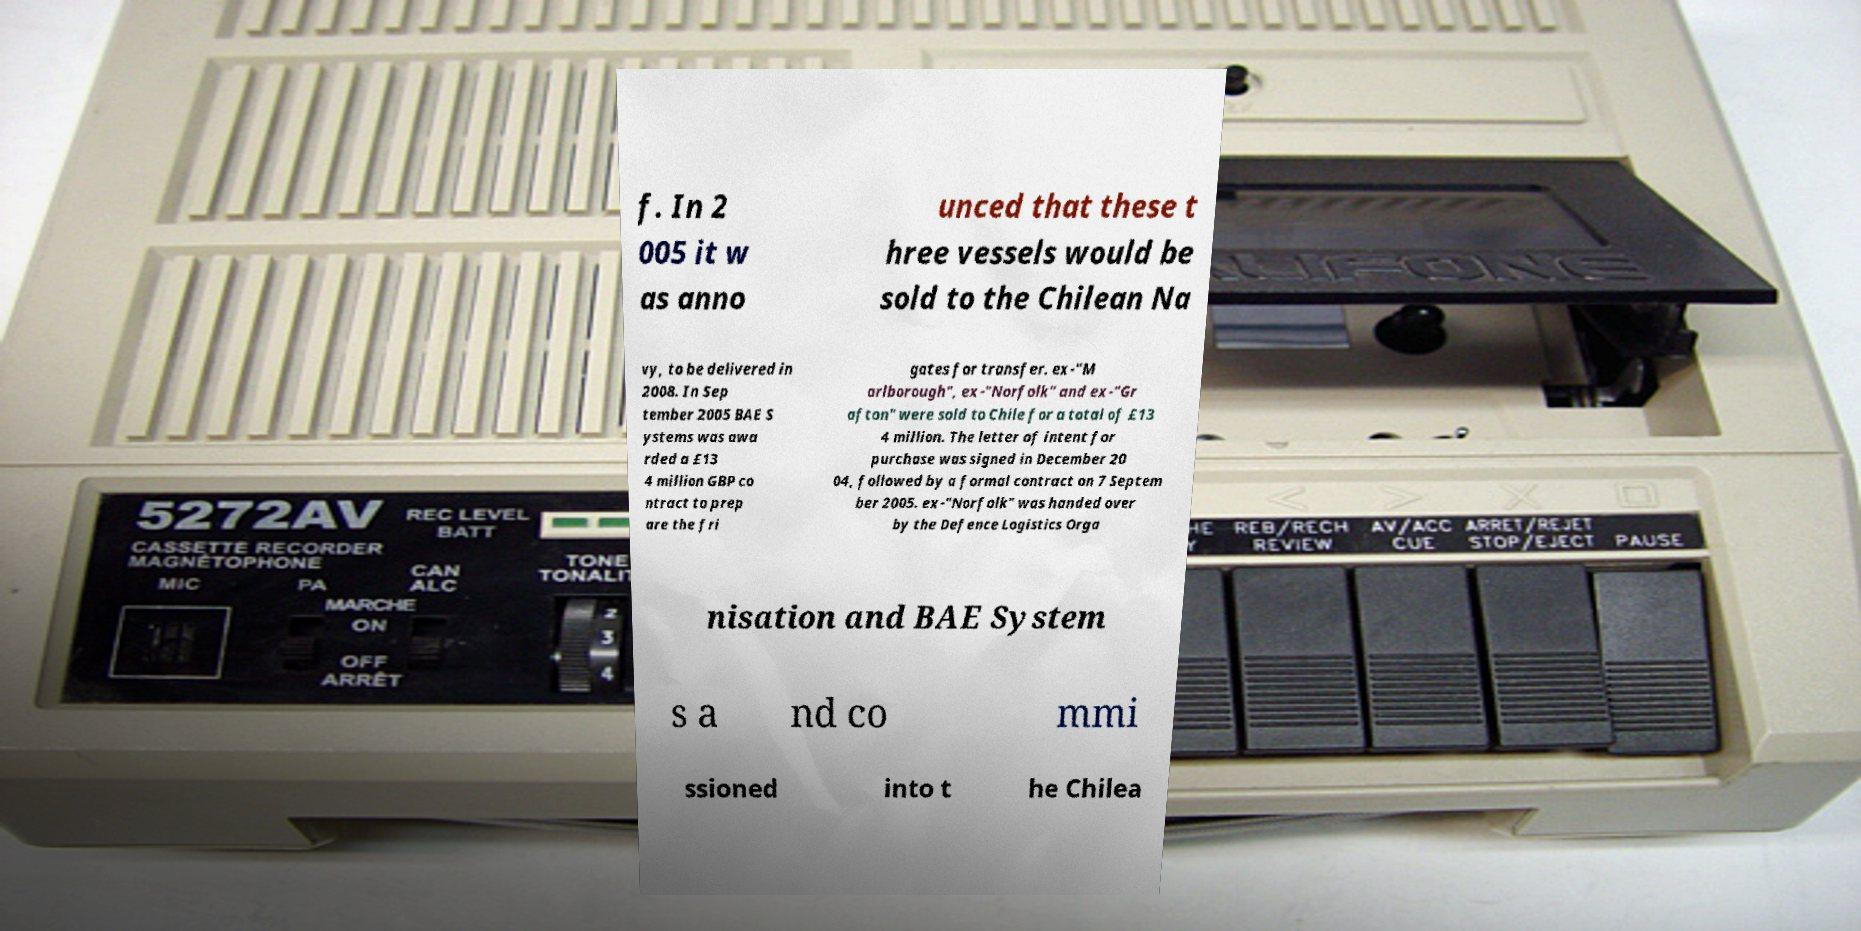There's text embedded in this image that I need extracted. Can you transcribe it verbatim? f. In 2 005 it w as anno unced that these t hree vessels would be sold to the Chilean Na vy, to be delivered in 2008. In Sep tember 2005 BAE S ystems was awa rded a £13 4 million GBP co ntract to prep are the fri gates for transfer. ex-"M arlborough", ex-"Norfolk" and ex-"Gr afton" were sold to Chile for a total of £13 4 million. The letter of intent for purchase was signed in December 20 04, followed by a formal contract on 7 Septem ber 2005. ex-"Norfolk" was handed over by the Defence Logistics Orga nisation and BAE System s a nd co mmi ssioned into t he Chilea 